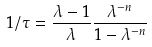Convert formula to latex. <formula><loc_0><loc_0><loc_500><loc_500>1 / \tau = \frac { \lambda - 1 } { \lambda } \frac { \lambda ^ { - n } } { 1 - \lambda ^ { - n } }</formula> 